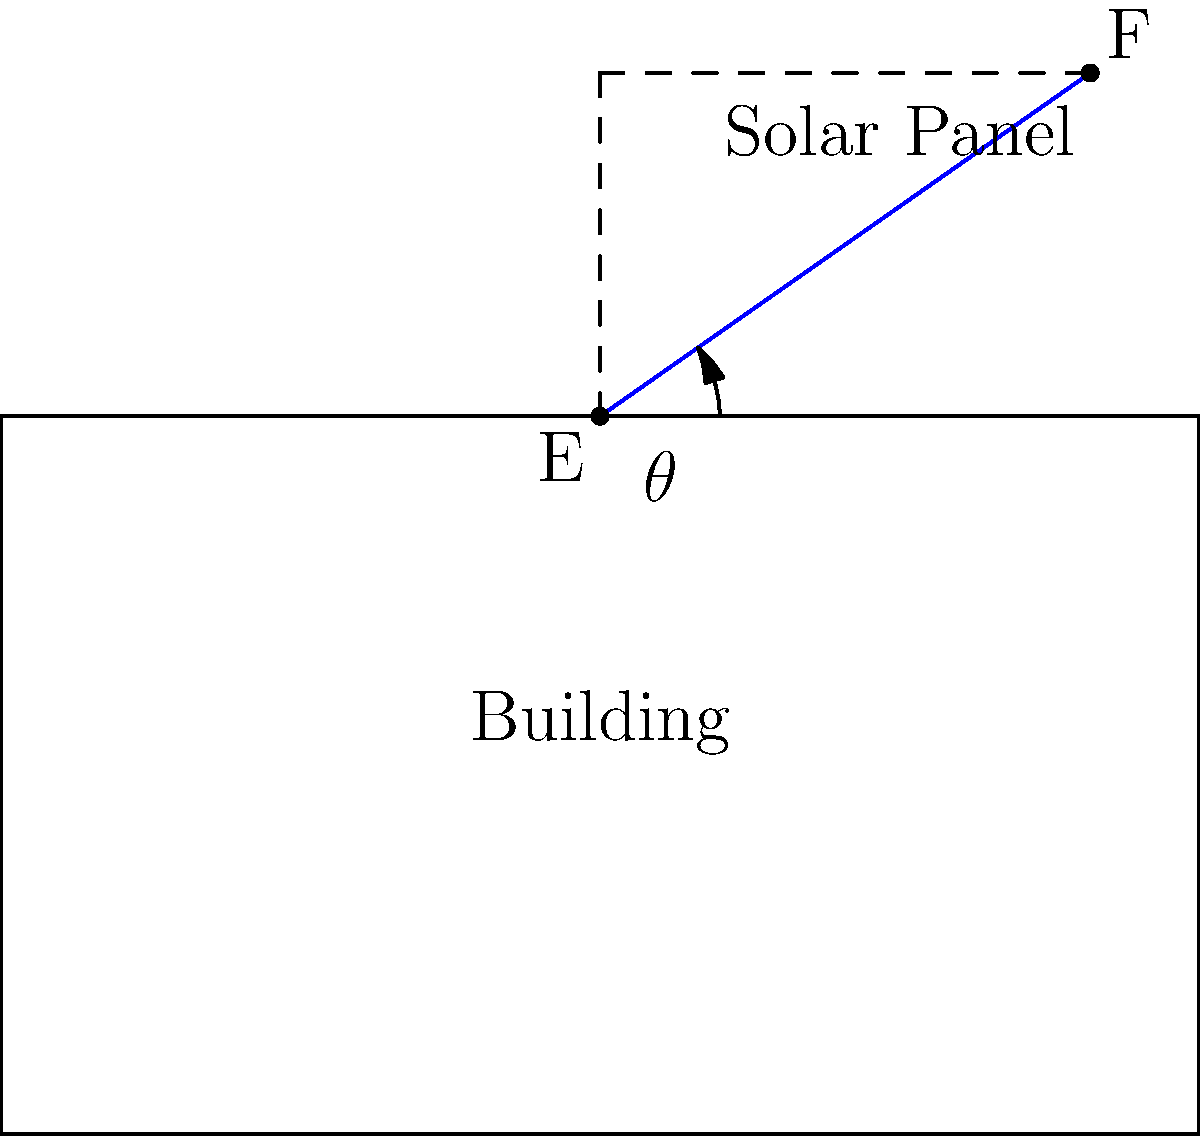As a future community leader interested in sustainable energy, you're tasked with optimizing the placement of solar panels on a local community center. The building has a flat roof, and you need to determine the optimal angle for the solar panels. Given that the maximum energy output occurs when the panel is perpendicular to the sun's rays, and the sun's average elevation angle in your area is 55°, what angle $\theta$ should the solar panels be tilted from the horizontal to maximize energy collection? Use the diagram and trigonometric functions to solve this problem. To solve this problem, we'll follow these steps:

1) First, we need to understand that for maximum energy output, the solar panel should be perpendicular to the sun's rays.

2) The sun's elevation angle is given as 55°. This is the angle between the sun's rays and the horizontal plane.

3) For the solar panel to be perpendicular to the sun's rays, it must form a right angle (90°) with them.

4) We can set up an equation:
   
   $$\theta + 55° = 90°$$

   Where $\theta$ is the angle we're looking for (the tilt of the solar panel from the horizontal).

5) Solving for $\theta$:
   
   $$\theta = 90° - 55° = 35°$$

6) We can verify this using trigonometry. If we consider a right triangle formed by the solar panel and the sun's rays:

   $$\tan(55°) = \frac{\text{opposite}}{\text{adjacent}} = \frac{1}{\tan(\theta)}$$

   $$\theta = \arctan(\frac{1}{\tan(55°)}) \approx 35°$$

Therefore, the solar panels should be tilted at an angle of 35° from the horizontal to maximize energy collection.
Answer: 35° 